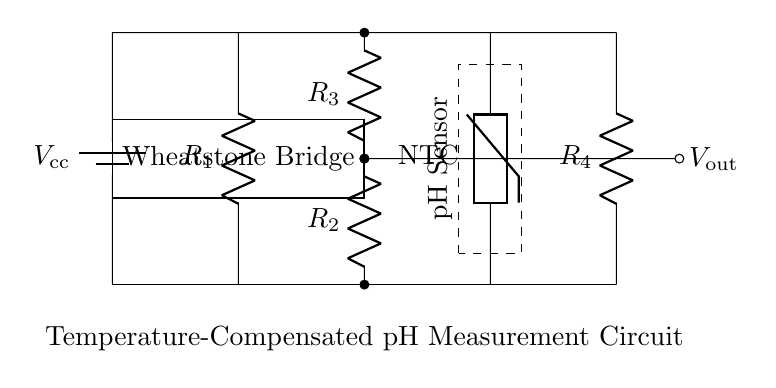What is the power supply voltage in the circuit? The circuit shows a battery labeled as V_sub_cc, indicating the power supply voltage needed for operation.
Answer: V_cc How many resistors are present in the circuit? By examining the diagram, there are four resistors identified as R_1, R_2, R_3, and R_4, making a total of four resistors overall in the circuit.
Answer: 4 What type of sensor is used in this circuit? The circuit contains a component labeled as a thermistor, specifying that it is a negative temperature coefficient (NTC) thermistor, which implies how it operates with temperature.
Answer: NTC What is the purpose of the Wheatstone bridge in this circuit? The Wheatstone bridge is used to measure the change in electrical resistance and compare the values, allowing accurate measurements of pH levels under temperature variations.
Answer: Measure pH What is the output voltage of the circuit? The output voltage, labeled as V_sub_out, is connected to the point between resistors R_2 and R_3, indicating its significance in the circuit’s function.
Answer: V_out How is temperature compensation achieved in this circuit? The presence of an NTC thermistor allows for temperature compensation by adjusting the circuit’s behavior based on temperature variations, maintaining accurate readings.
Answer: NTC thermistor What type of circuit is this diagram representing? This diagram represents a temperature-compensated bridge circuit specifically designed for the measurement of pH levels, indicating its purpose and function within food preservation techniques.
Answer: Bridge Circuit 